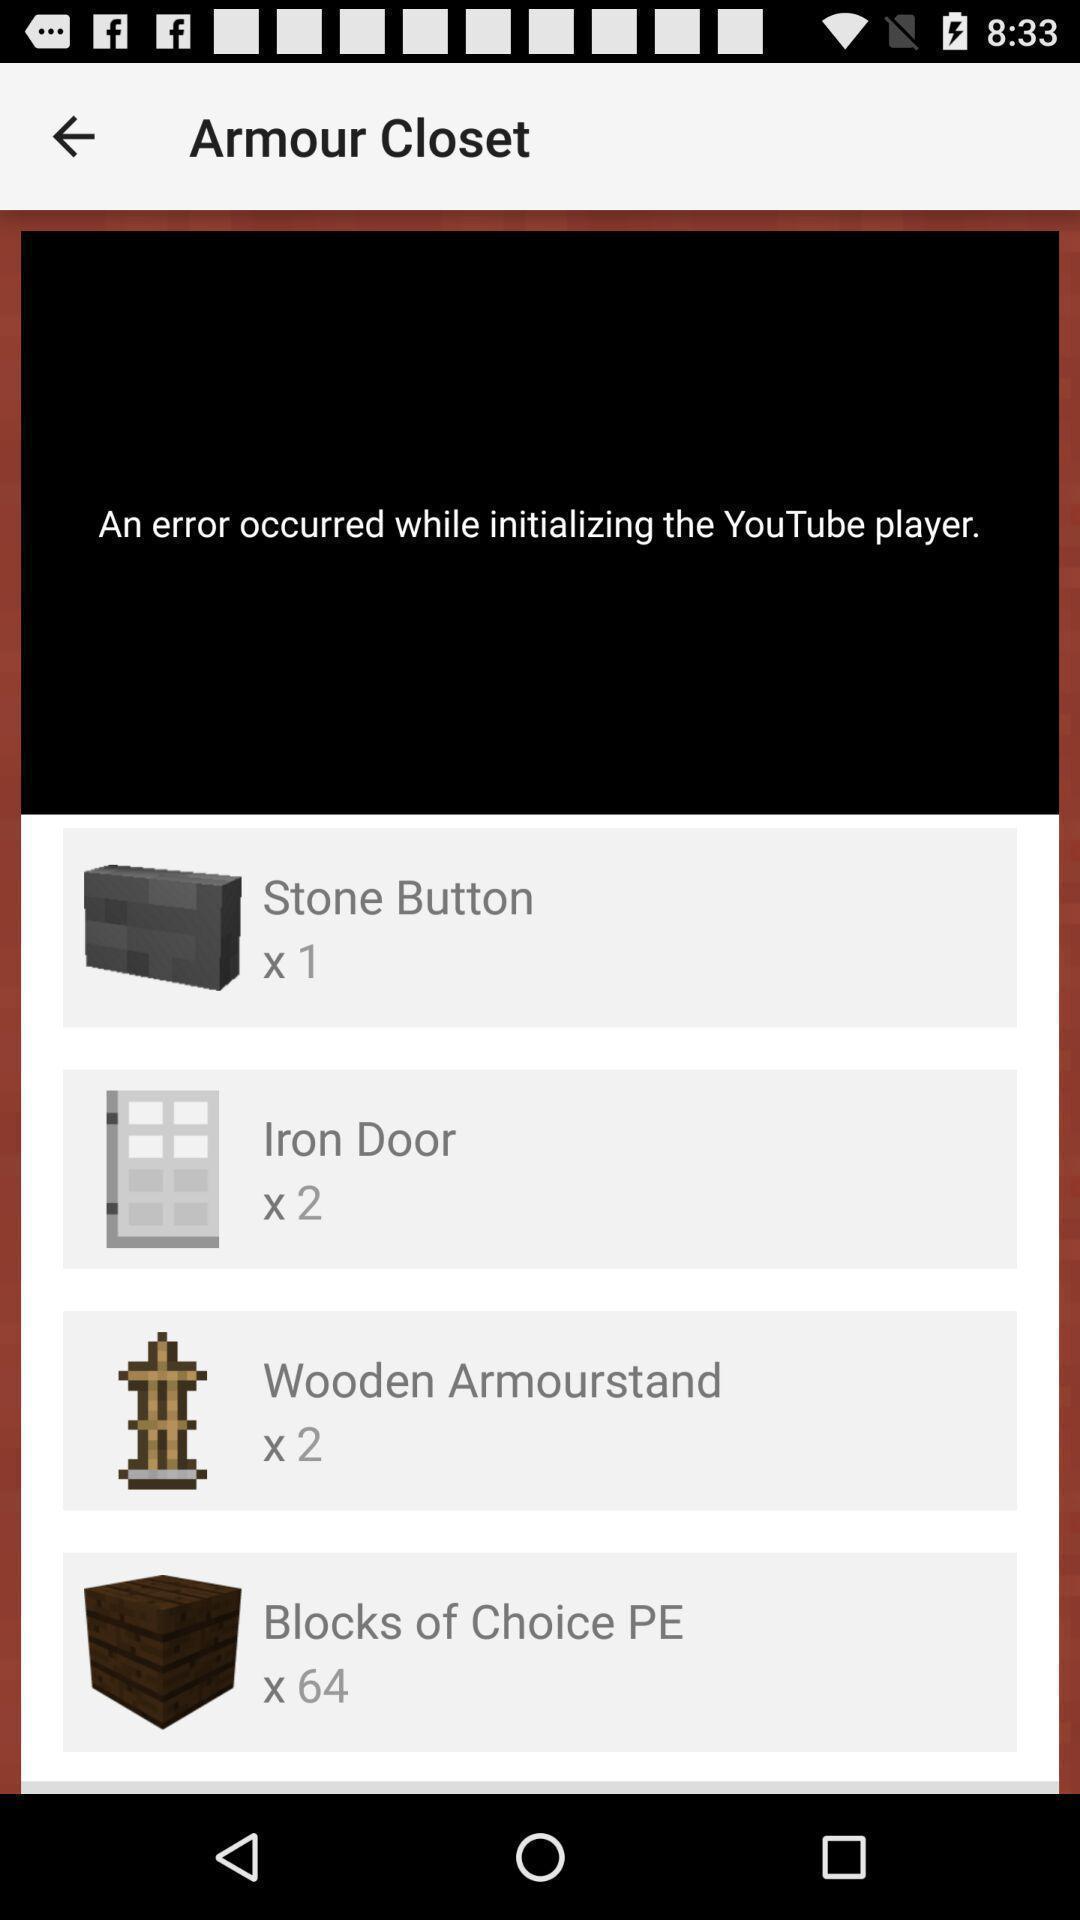Tell me what you see in this picture. Screen shows occurance of an error. 